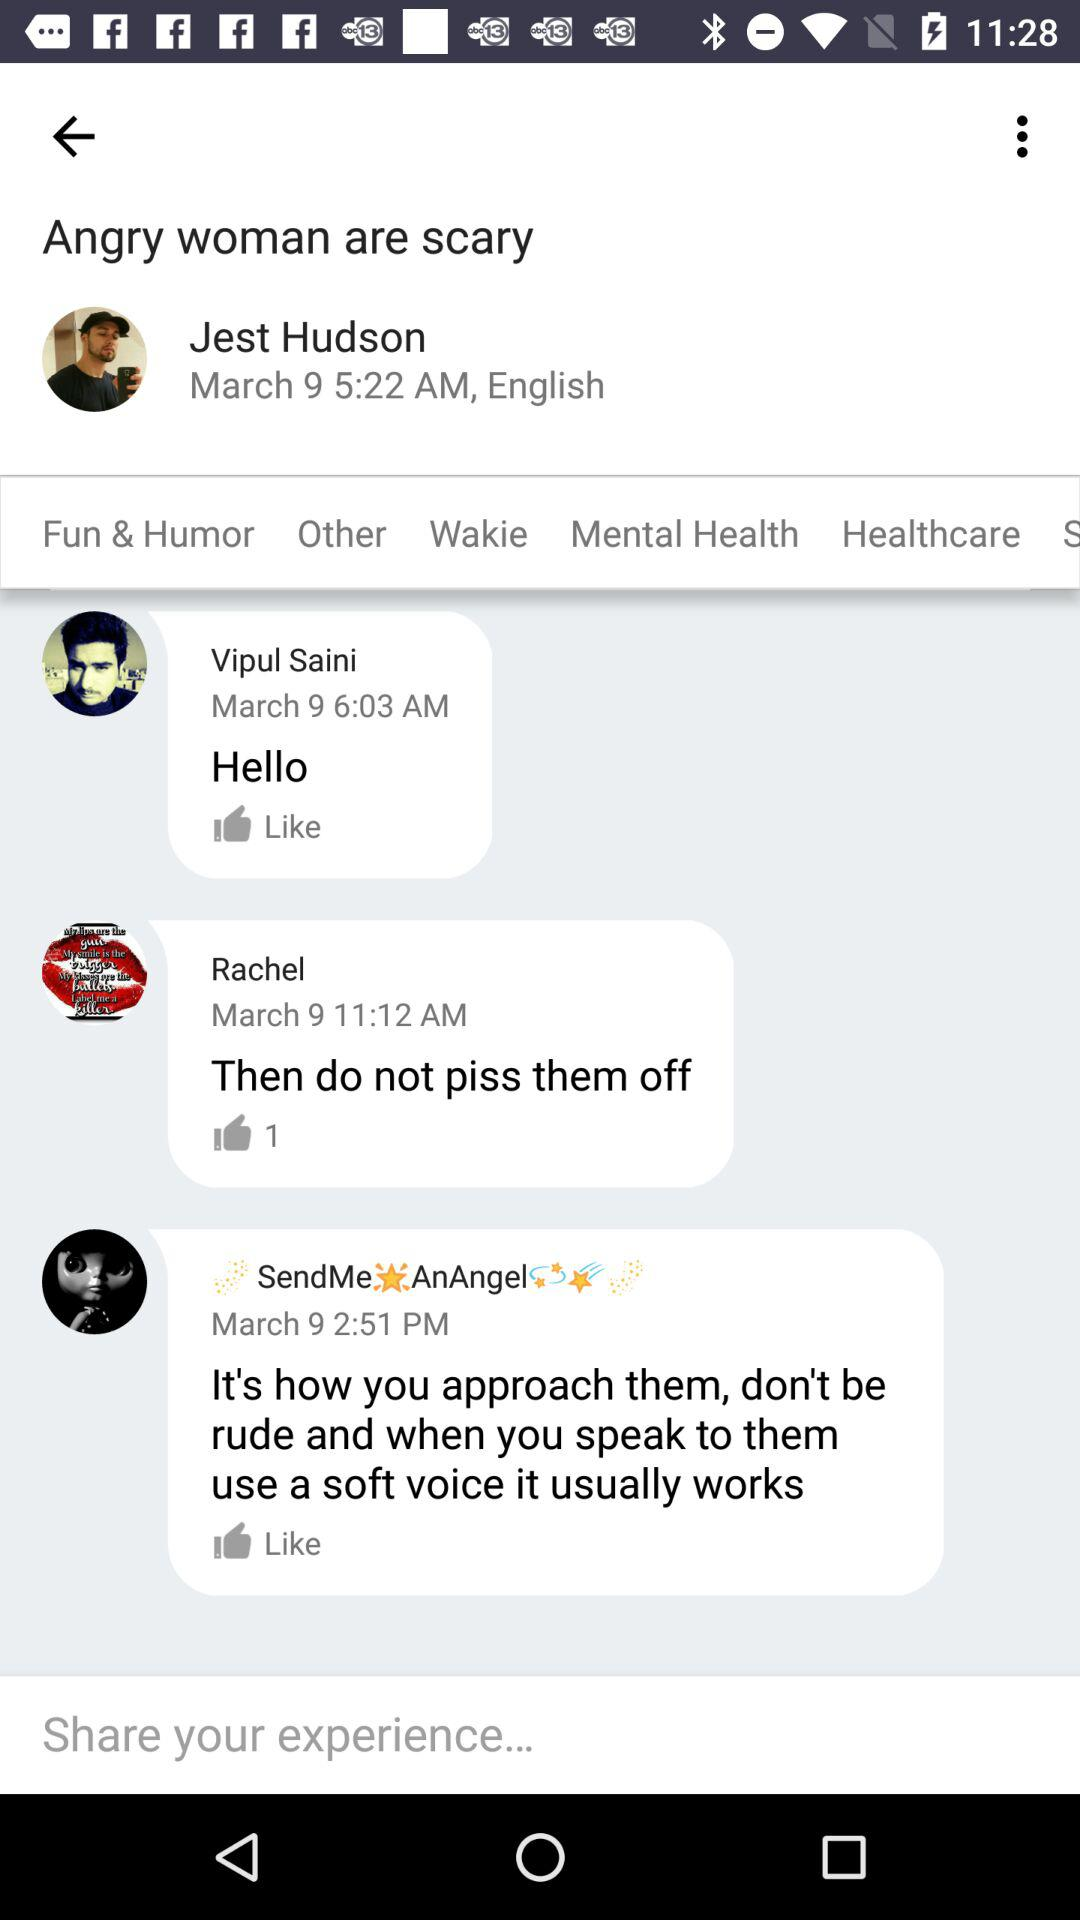What language does the user use? The user uses English. 